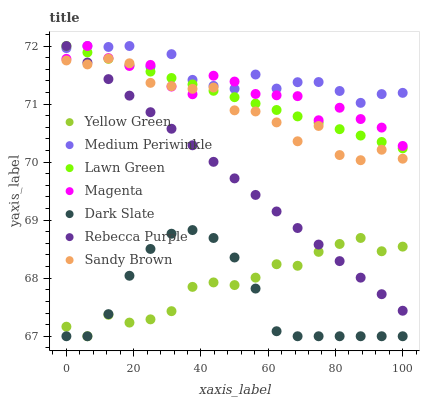Does Dark Slate have the minimum area under the curve?
Answer yes or no. Yes. Does Medium Periwinkle have the maximum area under the curve?
Answer yes or no. Yes. Does Yellow Green have the minimum area under the curve?
Answer yes or no. No. Does Yellow Green have the maximum area under the curve?
Answer yes or no. No. Is Rebecca Purple the smoothest?
Answer yes or no. Yes. Is Sandy Brown the roughest?
Answer yes or no. Yes. Is Yellow Green the smoothest?
Answer yes or no. No. Is Yellow Green the roughest?
Answer yes or no. No. Does Yellow Green have the lowest value?
Answer yes or no. Yes. Does Medium Periwinkle have the lowest value?
Answer yes or no. No. Does Magenta have the highest value?
Answer yes or no. Yes. Does Yellow Green have the highest value?
Answer yes or no. No. Is Dark Slate less than Magenta?
Answer yes or no. Yes. Is Magenta greater than Yellow Green?
Answer yes or no. Yes. Does Yellow Green intersect Rebecca Purple?
Answer yes or no. Yes. Is Yellow Green less than Rebecca Purple?
Answer yes or no. No. Is Yellow Green greater than Rebecca Purple?
Answer yes or no. No. Does Dark Slate intersect Magenta?
Answer yes or no. No. 